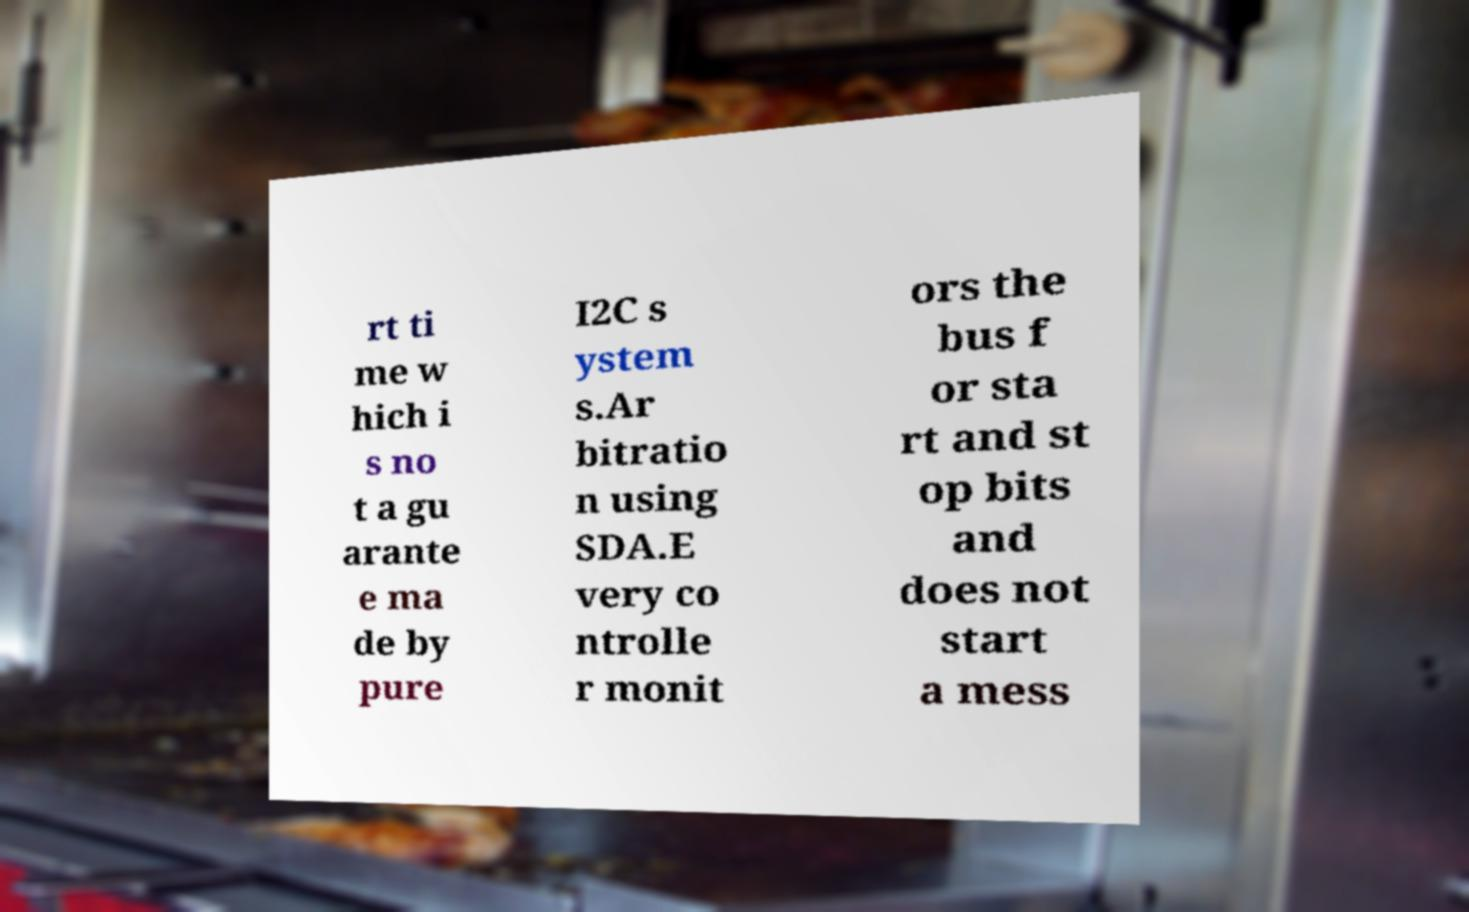There's text embedded in this image that I need extracted. Can you transcribe it verbatim? rt ti me w hich i s no t a gu arante e ma de by pure I2C s ystem s.Ar bitratio n using SDA.E very co ntrolle r monit ors the bus f or sta rt and st op bits and does not start a mess 